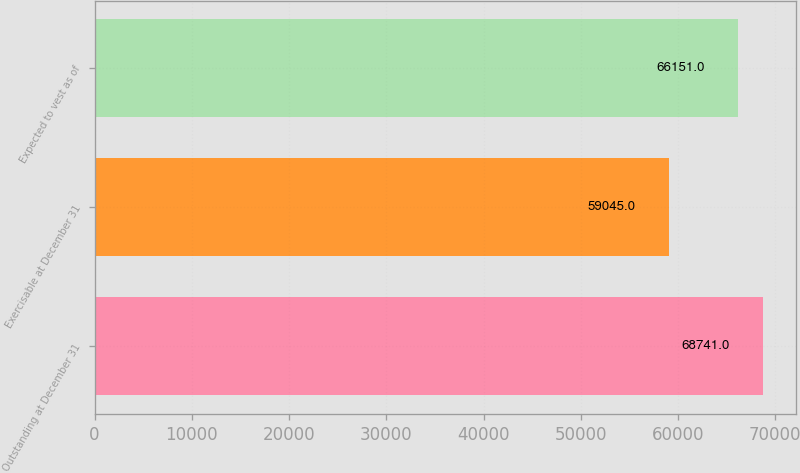<chart> <loc_0><loc_0><loc_500><loc_500><bar_chart><fcel>Outstanding at December 31<fcel>Exercisable at December 31<fcel>Expected to vest as of<nl><fcel>68741<fcel>59045<fcel>66151<nl></chart> 